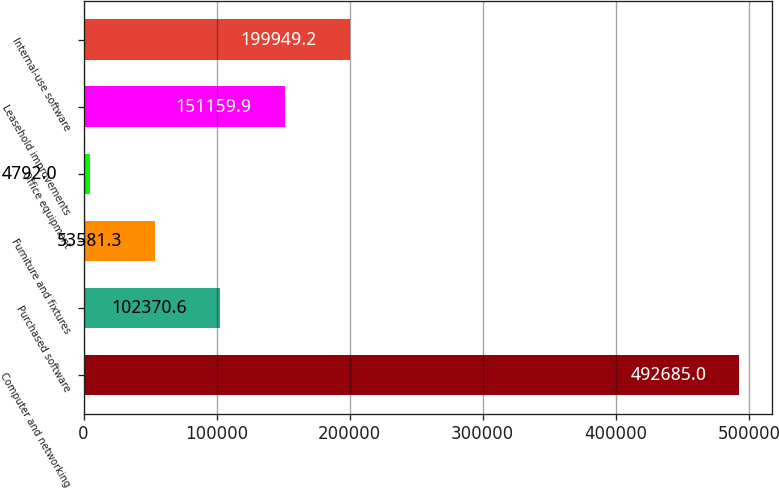<chart> <loc_0><loc_0><loc_500><loc_500><bar_chart><fcel>Computer and networking<fcel>Purchased software<fcel>Furniture and fixtures<fcel>Office equipment<fcel>Leasehold improvements<fcel>Internal-use software<nl><fcel>492685<fcel>102371<fcel>53581.3<fcel>4792<fcel>151160<fcel>199949<nl></chart> 